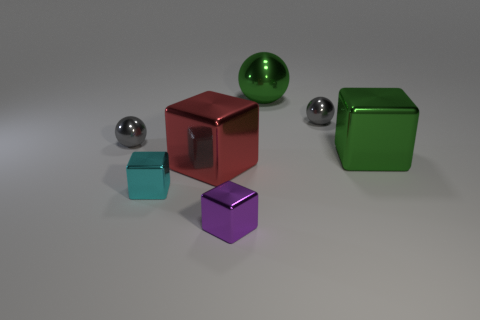Add 2 large red blocks. How many objects exist? 9 Subtract all balls. How many objects are left? 4 Add 5 large shiny blocks. How many large shiny blocks exist? 7 Subtract 0 yellow cylinders. How many objects are left? 7 Subtract all gray things. Subtract all big blocks. How many objects are left? 3 Add 4 tiny purple things. How many tiny purple things are left? 5 